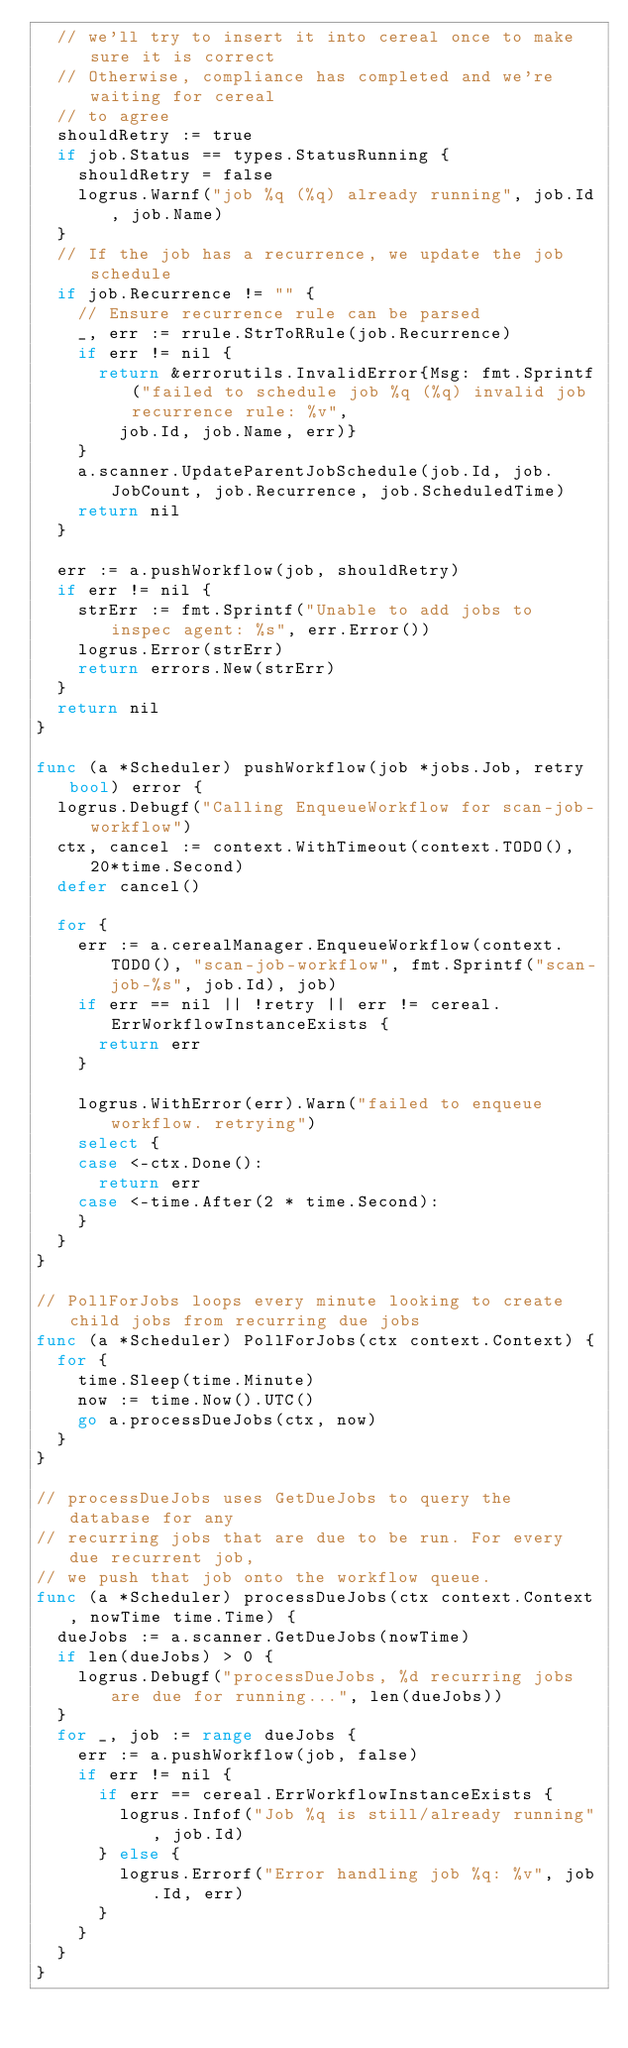<code> <loc_0><loc_0><loc_500><loc_500><_Go_>	// we'll try to insert it into cereal once to make sure it is correct
	// Otherwise, compliance has completed and we're waiting for cereal
	// to agree
	shouldRetry := true
	if job.Status == types.StatusRunning {
		shouldRetry = false
		logrus.Warnf("job %q (%q) already running", job.Id, job.Name)
	}
	// If the job has a recurrence, we update the job schedule
	if job.Recurrence != "" {
		// Ensure recurrence rule can be parsed
		_, err := rrule.StrToRRule(job.Recurrence)
		if err != nil {
			return &errorutils.InvalidError{Msg: fmt.Sprintf("failed to schedule job %q (%q) invalid job recurrence rule: %v",
				job.Id, job.Name, err)}
		}
		a.scanner.UpdateParentJobSchedule(job.Id, job.JobCount, job.Recurrence, job.ScheduledTime)
		return nil
	}

	err := a.pushWorkflow(job, shouldRetry)
	if err != nil {
		strErr := fmt.Sprintf("Unable to add jobs to inspec agent: %s", err.Error())
		logrus.Error(strErr)
		return errors.New(strErr)
	}
	return nil
}

func (a *Scheduler) pushWorkflow(job *jobs.Job, retry bool) error {
	logrus.Debugf("Calling EnqueueWorkflow for scan-job-workflow")
	ctx, cancel := context.WithTimeout(context.TODO(), 20*time.Second)
	defer cancel()

	for {
		err := a.cerealManager.EnqueueWorkflow(context.TODO(), "scan-job-workflow", fmt.Sprintf("scan-job-%s", job.Id), job)
		if err == nil || !retry || err != cereal.ErrWorkflowInstanceExists {
			return err
		}

		logrus.WithError(err).Warn("failed to enqueue workflow. retrying")
		select {
		case <-ctx.Done():
			return err
		case <-time.After(2 * time.Second):
		}
	}
}

// PollForJobs loops every minute looking to create child jobs from recurring due jobs
func (a *Scheduler) PollForJobs(ctx context.Context) {
	for {
		time.Sleep(time.Minute)
		now := time.Now().UTC()
		go a.processDueJobs(ctx, now)
	}
}

// processDueJobs uses GetDueJobs to query the database for any
// recurring jobs that are due to be run. For every due recurrent job,
// we push that job onto the workflow queue.
func (a *Scheduler) processDueJobs(ctx context.Context, nowTime time.Time) {
	dueJobs := a.scanner.GetDueJobs(nowTime)
	if len(dueJobs) > 0 {
		logrus.Debugf("processDueJobs, %d recurring jobs are due for running...", len(dueJobs))
	}
	for _, job := range dueJobs {
		err := a.pushWorkflow(job, false)
		if err != nil {
			if err == cereal.ErrWorkflowInstanceExists {
				logrus.Infof("Job %q is still/already running", job.Id)
			} else {
				logrus.Errorf("Error handling job %q: %v", job.Id, err)
			}
		}
	}
}
</code> 